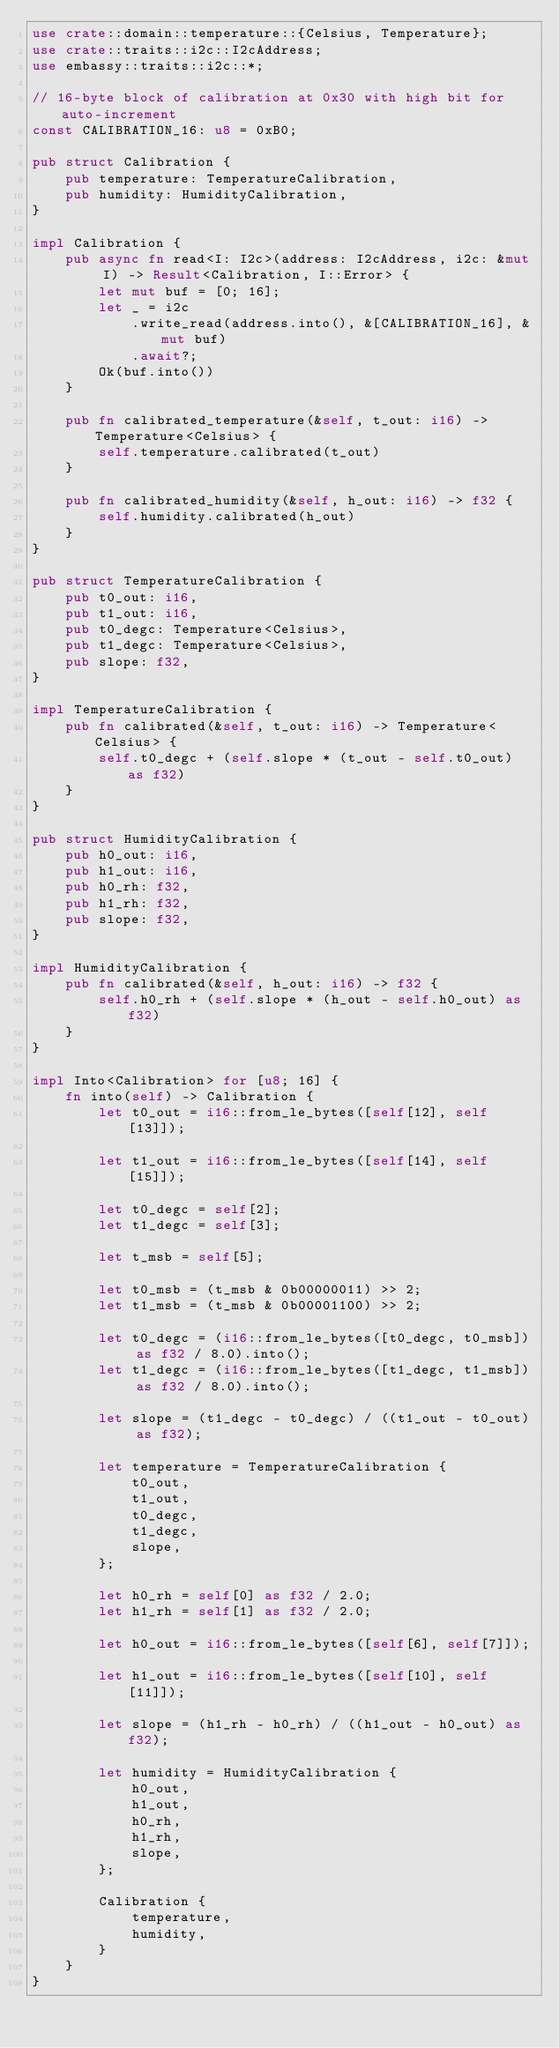Convert code to text. <code><loc_0><loc_0><loc_500><loc_500><_Rust_>use crate::domain::temperature::{Celsius, Temperature};
use crate::traits::i2c::I2cAddress;
use embassy::traits::i2c::*;

// 16-byte block of calibration at 0x30 with high bit for auto-increment
const CALIBRATION_16: u8 = 0xB0;

pub struct Calibration {
    pub temperature: TemperatureCalibration,
    pub humidity: HumidityCalibration,
}

impl Calibration {
    pub async fn read<I: I2c>(address: I2cAddress, i2c: &mut I) -> Result<Calibration, I::Error> {
        let mut buf = [0; 16];
        let _ = i2c
            .write_read(address.into(), &[CALIBRATION_16], &mut buf)
            .await?;
        Ok(buf.into())
    }

    pub fn calibrated_temperature(&self, t_out: i16) -> Temperature<Celsius> {
        self.temperature.calibrated(t_out)
    }

    pub fn calibrated_humidity(&self, h_out: i16) -> f32 {
        self.humidity.calibrated(h_out)
    }
}

pub struct TemperatureCalibration {
    pub t0_out: i16,
    pub t1_out: i16,
    pub t0_degc: Temperature<Celsius>,
    pub t1_degc: Temperature<Celsius>,
    pub slope: f32,
}

impl TemperatureCalibration {
    pub fn calibrated(&self, t_out: i16) -> Temperature<Celsius> {
        self.t0_degc + (self.slope * (t_out - self.t0_out) as f32)
    }
}

pub struct HumidityCalibration {
    pub h0_out: i16,
    pub h1_out: i16,
    pub h0_rh: f32,
    pub h1_rh: f32,
    pub slope: f32,
}

impl HumidityCalibration {
    pub fn calibrated(&self, h_out: i16) -> f32 {
        self.h0_rh + (self.slope * (h_out - self.h0_out) as f32)
    }
}

impl Into<Calibration> for [u8; 16] {
    fn into(self) -> Calibration {
        let t0_out = i16::from_le_bytes([self[12], self[13]]);

        let t1_out = i16::from_le_bytes([self[14], self[15]]);

        let t0_degc = self[2];
        let t1_degc = self[3];

        let t_msb = self[5];

        let t0_msb = (t_msb & 0b00000011) >> 2;
        let t1_msb = (t_msb & 0b00001100) >> 2;

        let t0_degc = (i16::from_le_bytes([t0_degc, t0_msb]) as f32 / 8.0).into();
        let t1_degc = (i16::from_le_bytes([t1_degc, t1_msb]) as f32 / 8.0).into();

        let slope = (t1_degc - t0_degc) / ((t1_out - t0_out) as f32);

        let temperature = TemperatureCalibration {
            t0_out,
            t1_out,
            t0_degc,
            t1_degc,
            slope,
        };

        let h0_rh = self[0] as f32 / 2.0;
        let h1_rh = self[1] as f32 / 2.0;

        let h0_out = i16::from_le_bytes([self[6], self[7]]);

        let h1_out = i16::from_le_bytes([self[10], self[11]]);

        let slope = (h1_rh - h0_rh) / ((h1_out - h0_out) as f32);

        let humidity = HumidityCalibration {
            h0_out,
            h1_out,
            h0_rh,
            h1_rh,
            slope,
        };

        Calibration {
            temperature,
            humidity,
        }
    }
}
</code> 